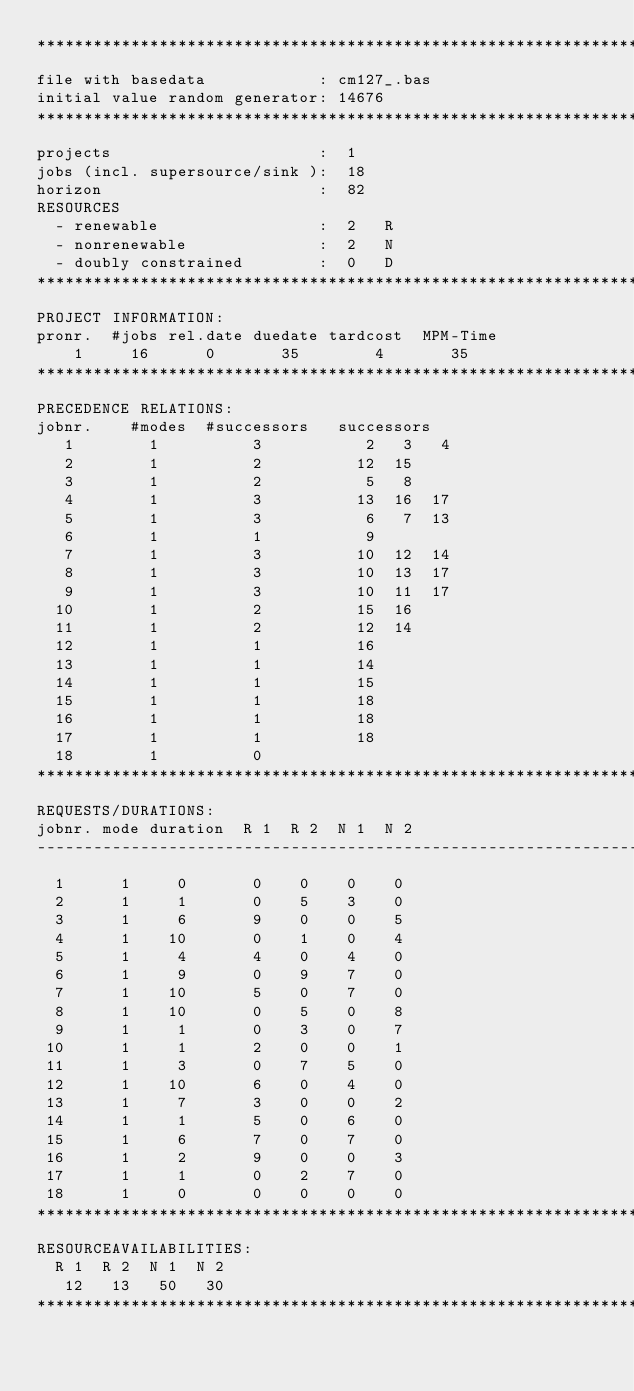<code> <loc_0><loc_0><loc_500><loc_500><_ObjectiveC_>************************************************************************
file with basedata            : cm127_.bas
initial value random generator: 14676
************************************************************************
projects                      :  1
jobs (incl. supersource/sink ):  18
horizon                       :  82
RESOURCES
  - renewable                 :  2   R
  - nonrenewable              :  2   N
  - doubly constrained        :  0   D
************************************************************************
PROJECT INFORMATION:
pronr.  #jobs rel.date duedate tardcost  MPM-Time
    1     16      0       35        4       35
************************************************************************
PRECEDENCE RELATIONS:
jobnr.    #modes  #successors   successors
   1        1          3           2   3   4
   2        1          2          12  15
   3        1          2           5   8
   4        1          3          13  16  17
   5        1          3           6   7  13
   6        1          1           9
   7        1          3          10  12  14
   8        1          3          10  13  17
   9        1          3          10  11  17
  10        1          2          15  16
  11        1          2          12  14
  12        1          1          16
  13        1          1          14
  14        1          1          15
  15        1          1          18
  16        1          1          18
  17        1          1          18
  18        1          0        
************************************************************************
REQUESTS/DURATIONS:
jobnr. mode duration  R 1  R 2  N 1  N 2
------------------------------------------------------------------------
  1      1     0       0    0    0    0
  2      1     1       0    5    3    0
  3      1     6       9    0    0    5
  4      1    10       0    1    0    4
  5      1     4       4    0    4    0
  6      1     9       0    9    7    0
  7      1    10       5    0    7    0
  8      1    10       0    5    0    8
  9      1     1       0    3    0    7
 10      1     1       2    0    0    1
 11      1     3       0    7    5    0
 12      1    10       6    0    4    0
 13      1     7       3    0    0    2
 14      1     1       5    0    6    0
 15      1     6       7    0    7    0
 16      1     2       9    0    0    3
 17      1     1       0    2    7    0
 18      1     0       0    0    0    0
************************************************************************
RESOURCEAVAILABILITIES:
  R 1  R 2  N 1  N 2
   12   13   50   30
************************************************************************
</code> 